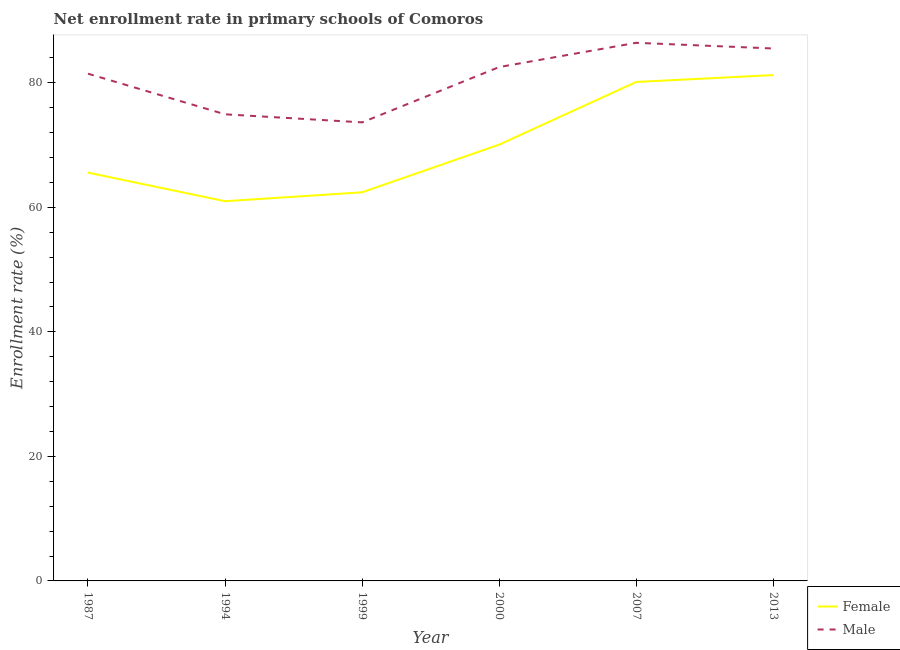How many different coloured lines are there?
Keep it short and to the point. 2. Does the line corresponding to enrollment rate of female students intersect with the line corresponding to enrollment rate of male students?
Make the answer very short. No. Is the number of lines equal to the number of legend labels?
Give a very brief answer. Yes. What is the enrollment rate of male students in 1987?
Offer a terse response. 81.47. Across all years, what is the maximum enrollment rate of female students?
Provide a succinct answer. 81.24. Across all years, what is the minimum enrollment rate of female students?
Keep it short and to the point. 60.98. In which year was the enrollment rate of male students minimum?
Your response must be concise. 1999. What is the total enrollment rate of female students in the graph?
Your response must be concise. 420.43. What is the difference between the enrollment rate of female students in 2000 and that in 2013?
Your answer should be compact. -11.17. What is the difference between the enrollment rate of female students in 1987 and the enrollment rate of male students in 2007?
Make the answer very short. -20.85. What is the average enrollment rate of female students per year?
Give a very brief answer. 70.07. In the year 2000, what is the difference between the enrollment rate of male students and enrollment rate of female students?
Ensure brevity in your answer.  12.46. In how many years, is the enrollment rate of female students greater than 12 %?
Offer a very short reply. 6. What is the ratio of the enrollment rate of female students in 2000 to that in 2013?
Keep it short and to the point. 0.86. Is the difference between the enrollment rate of female students in 1994 and 2013 greater than the difference between the enrollment rate of male students in 1994 and 2013?
Give a very brief answer. No. What is the difference between the highest and the second highest enrollment rate of male students?
Your answer should be very brief. 0.92. What is the difference between the highest and the lowest enrollment rate of female students?
Provide a short and direct response. 20.26. Is the sum of the enrollment rate of female students in 1999 and 2007 greater than the maximum enrollment rate of male students across all years?
Your response must be concise. Yes. How many years are there in the graph?
Give a very brief answer. 6. What is the difference between two consecutive major ticks on the Y-axis?
Give a very brief answer. 20. Does the graph contain grids?
Offer a terse response. No. What is the title of the graph?
Make the answer very short. Net enrollment rate in primary schools of Comoros. Does "Under-five" appear as one of the legend labels in the graph?
Give a very brief answer. No. What is the label or title of the Y-axis?
Your answer should be compact. Enrollment rate (%). What is the Enrollment rate (%) of Female in 1987?
Your answer should be very brief. 65.58. What is the Enrollment rate (%) in Male in 1987?
Ensure brevity in your answer.  81.47. What is the Enrollment rate (%) of Female in 1994?
Ensure brevity in your answer.  60.98. What is the Enrollment rate (%) in Male in 1994?
Offer a very short reply. 74.94. What is the Enrollment rate (%) of Female in 1999?
Make the answer very short. 62.42. What is the Enrollment rate (%) in Male in 1999?
Your response must be concise. 73.65. What is the Enrollment rate (%) in Female in 2000?
Ensure brevity in your answer.  70.07. What is the Enrollment rate (%) in Male in 2000?
Offer a very short reply. 82.53. What is the Enrollment rate (%) in Female in 2007?
Your response must be concise. 80.14. What is the Enrollment rate (%) of Male in 2007?
Your answer should be compact. 86.43. What is the Enrollment rate (%) of Female in 2013?
Your response must be concise. 81.24. What is the Enrollment rate (%) of Male in 2013?
Ensure brevity in your answer.  85.51. Across all years, what is the maximum Enrollment rate (%) of Female?
Provide a succinct answer. 81.24. Across all years, what is the maximum Enrollment rate (%) of Male?
Your response must be concise. 86.43. Across all years, what is the minimum Enrollment rate (%) in Female?
Keep it short and to the point. 60.98. Across all years, what is the minimum Enrollment rate (%) in Male?
Your response must be concise. 73.65. What is the total Enrollment rate (%) of Female in the graph?
Ensure brevity in your answer.  420.43. What is the total Enrollment rate (%) of Male in the graph?
Offer a very short reply. 484.53. What is the difference between the Enrollment rate (%) in Female in 1987 and that in 1994?
Your response must be concise. 4.6. What is the difference between the Enrollment rate (%) in Male in 1987 and that in 1994?
Provide a short and direct response. 6.52. What is the difference between the Enrollment rate (%) of Female in 1987 and that in 1999?
Your answer should be very brief. 3.17. What is the difference between the Enrollment rate (%) in Male in 1987 and that in 1999?
Offer a terse response. 7.82. What is the difference between the Enrollment rate (%) of Female in 1987 and that in 2000?
Offer a terse response. -4.49. What is the difference between the Enrollment rate (%) in Male in 1987 and that in 2000?
Ensure brevity in your answer.  -1.07. What is the difference between the Enrollment rate (%) of Female in 1987 and that in 2007?
Your answer should be very brief. -14.56. What is the difference between the Enrollment rate (%) in Male in 1987 and that in 2007?
Your response must be concise. -4.96. What is the difference between the Enrollment rate (%) in Female in 1987 and that in 2013?
Make the answer very short. -15.66. What is the difference between the Enrollment rate (%) of Male in 1987 and that in 2013?
Your answer should be very brief. -4.05. What is the difference between the Enrollment rate (%) of Female in 1994 and that in 1999?
Your answer should be compact. -1.43. What is the difference between the Enrollment rate (%) of Male in 1994 and that in 1999?
Ensure brevity in your answer.  1.3. What is the difference between the Enrollment rate (%) in Female in 1994 and that in 2000?
Give a very brief answer. -9.09. What is the difference between the Enrollment rate (%) of Male in 1994 and that in 2000?
Your response must be concise. -7.59. What is the difference between the Enrollment rate (%) of Female in 1994 and that in 2007?
Make the answer very short. -19.15. What is the difference between the Enrollment rate (%) in Male in 1994 and that in 2007?
Offer a very short reply. -11.48. What is the difference between the Enrollment rate (%) in Female in 1994 and that in 2013?
Make the answer very short. -20.26. What is the difference between the Enrollment rate (%) in Male in 1994 and that in 2013?
Your answer should be very brief. -10.57. What is the difference between the Enrollment rate (%) of Female in 1999 and that in 2000?
Provide a short and direct response. -7.66. What is the difference between the Enrollment rate (%) in Male in 1999 and that in 2000?
Provide a succinct answer. -8.89. What is the difference between the Enrollment rate (%) of Female in 1999 and that in 2007?
Give a very brief answer. -17.72. What is the difference between the Enrollment rate (%) in Male in 1999 and that in 2007?
Your answer should be compact. -12.78. What is the difference between the Enrollment rate (%) of Female in 1999 and that in 2013?
Offer a very short reply. -18.83. What is the difference between the Enrollment rate (%) of Male in 1999 and that in 2013?
Offer a terse response. -11.86. What is the difference between the Enrollment rate (%) of Female in 2000 and that in 2007?
Your answer should be compact. -10.07. What is the difference between the Enrollment rate (%) of Male in 2000 and that in 2007?
Offer a very short reply. -3.89. What is the difference between the Enrollment rate (%) of Female in 2000 and that in 2013?
Offer a very short reply. -11.17. What is the difference between the Enrollment rate (%) of Male in 2000 and that in 2013?
Give a very brief answer. -2.98. What is the difference between the Enrollment rate (%) in Female in 2007 and that in 2013?
Give a very brief answer. -1.11. What is the difference between the Enrollment rate (%) in Male in 2007 and that in 2013?
Ensure brevity in your answer.  0.92. What is the difference between the Enrollment rate (%) in Female in 1987 and the Enrollment rate (%) in Male in 1994?
Your response must be concise. -9.36. What is the difference between the Enrollment rate (%) in Female in 1987 and the Enrollment rate (%) in Male in 1999?
Provide a succinct answer. -8.07. What is the difference between the Enrollment rate (%) in Female in 1987 and the Enrollment rate (%) in Male in 2000?
Your response must be concise. -16.95. What is the difference between the Enrollment rate (%) in Female in 1987 and the Enrollment rate (%) in Male in 2007?
Offer a terse response. -20.85. What is the difference between the Enrollment rate (%) in Female in 1987 and the Enrollment rate (%) in Male in 2013?
Make the answer very short. -19.93. What is the difference between the Enrollment rate (%) in Female in 1994 and the Enrollment rate (%) in Male in 1999?
Offer a terse response. -12.66. What is the difference between the Enrollment rate (%) in Female in 1994 and the Enrollment rate (%) in Male in 2000?
Provide a short and direct response. -21.55. What is the difference between the Enrollment rate (%) of Female in 1994 and the Enrollment rate (%) of Male in 2007?
Give a very brief answer. -25.44. What is the difference between the Enrollment rate (%) of Female in 1994 and the Enrollment rate (%) of Male in 2013?
Your answer should be compact. -24.53. What is the difference between the Enrollment rate (%) of Female in 1999 and the Enrollment rate (%) of Male in 2000?
Offer a very short reply. -20.12. What is the difference between the Enrollment rate (%) in Female in 1999 and the Enrollment rate (%) in Male in 2007?
Your answer should be compact. -24.01. What is the difference between the Enrollment rate (%) in Female in 1999 and the Enrollment rate (%) in Male in 2013?
Your response must be concise. -23.1. What is the difference between the Enrollment rate (%) of Female in 2000 and the Enrollment rate (%) of Male in 2007?
Your answer should be compact. -16.36. What is the difference between the Enrollment rate (%) in Female in 2000 and the Enrollment rate (%) in Male in 2013?
Provide a succinct answer. -15.44. What is the difference between the Enrollment rate (%) in Female in 2007 and the Enrollment rate (%) in Male in 2013?
Provide a short and direct response. -5.38. What is the average Enrollment rate (%) in Female per year?
Keep it short and to the point. 70.07. What is the average Enrollment rate (%) in Male per year?
Give a very brief answer. 80.76. In the year 1987, what is the difference between the Enrollment rate (%) in Female and Enrollment rate (%) in Male?
Offer a very short reply. -15.89. In the year 1994, what is the difference between the Enrollment rate (%) of Female and Enrollment rate (%) of Male?
Give a very brief answer. -13.96. In the year 1999, what is the difference between the Enrollment rate (%) in Female and Enrollment rate (%) in Male?
Offer a terse response. -11.23. In the year 2000, what is the difference between the Enrollment rate (%) in Female and Enrollment rate (%) in Male?
Your response must be concise. -12.46. In the year 2007, what is the difference between the Enrollment rate (%) of Female and Enrollment rate (%) of Male?
Your answer should be very brief. -6.29. In the year 2013, what is the difference between the Enrollment rate (%) of Female and Enrollment rate (%) of Male?
Your answer should be compact. -4.27. What is the ratio of the Enrollment rate (%) in Female in 1987 to that in 1994?
Keep it short and to the point. 1.08. What is the ratio of the Enrollment rate (%) of Male in 1987 to that in 1994?
Offer a very short reply. 1.09. What is the ratio of the Enrollment rate (%) of Female in 1987 to that in 1999?
Your response must be concise. 1.05. What is the ratio of the Enrollment rate (%) of Male in 1987 to that in 1999?
Provide a succinct answer. 1.11. What is the ratio of the Enrollment rate (%) of Female in 1987 to that in 2000?
Make the answer very short. 0.94. What is the ratio of the Enrollment rate (%) of Male in 1987 to that in 2000?
Ensure brevity in your answer.  0.99. What is the ratio of the Enrollment rate (%) of Female in 1987 to that in 2007?
Provide a succinct answer. 0.82. What is the ratio of the Enrollment rate (%) of Male in 1987 to that in 2007?
Offer a very short reply. 0.94. What is the ratio of the Enrollment rate (%) of Female in 1987 to that in 2013?
Your response must be concise. 0.81. What is the ratio of the Enrollment rate (%) in Male in 1987 to that in 2013?
Offer a very short reply. 0.95. What is the ratio of the Enrollment rate (%) of Female in 1994 to that in 1999?
Provide a short and direct response. 0.98. What is the ratio of the Enrollment rate (%) in Male in 1994 to that in 1999?
Offer a very short reply. 1.02. What is the ratio of the Enrollment rate (%) in Female in 1994 to that in 2000?
Provide a succinct answer. 0.87. What is the ratio of the Enrollment rate (%) of Male in 1994 to that in 2000?
Ensure brevity in your answer.  0.91. What is the ratio of the Enrollment rate (%) in Female in 1994 to that in 2007?
Offer a very short reply. 0.76. What is the ratio of the Enrollment rate (%) in Male in 1994 to that in 2007?
Provide a short and direct response. 0.87. What is the ratio of the Enrollment rate (%) of Female in 1994 to that in 2013?
Offer a terse response. 0.75. What is the ratio of the Enrollment rate (%) in Male in 1994 to that in 2013?
Give a very brief answer. 0.88. What is the ratio of the Enrollment rate (%) in Female in 1999 to that in 2000?
Offer a terse response. 0.89. What is the ratio of the Enrollment rate (%) of Male in 1999 to that in 2000?
Your answer should be compact. 0.89. What is the ratio of the Enrollment rate (%) of Female in 1999 to that in 2007?
Offer a terse response. 0.78. What is the ratio of the Enrollment rate (%) in Male in 1999 to that in 2007?
Offer a very short reply. 0.85. What is the ratio of the Enrollment rate (%) in Female in 1999 to that in 2013?
Offer a terse response. 0.77. What is the ratio of the Enrollment rate (%) in Male in 1999 to that in 2013?
Ensure brevity in your answer.  0.86. What is the ratio of the Enrollment rate (%) of Female in 2000 to that in 2007?
Keep it short and to the point. 0.87. What is the ratio of the Enrollment rate (%) of Male in 2000 to that in 2007?
Ensure brevity in your answer.  0.95. What is the ratio of the Enrollment rate (%) in Female in 2000 to that in 2013?
Provide a succinct answer. 0.86. What is the ratio of the Enrollment rate (%) in Male in 2000 to that in 2013?
Give a very brief answer. 0.97. What is the ratio of the Enrollment rate (%) in Female in 2007 to that in 2013?
Make the answer very short. 0.99. What is the ratio of the Enrollment rate (%) of Male in 2007 to that in 2013?
Provide a succinct answer. 1.01. What is the difference between the highest and the second highest Enrollment rate (%) in Female?
Give a very brief answer. 1.11. What is the difference between the highest and the second highest Enrollment rate (%) of Male?
Your answer should be very brief. 0.92. What is the difference between the highest and the lowest Enrollment rate (%) in Female?
Offer a very short reply. 20.26. What is the difference between the highest and the lowest Enrollment rate (%) of Male?
Give a very brief answer. 12.78. 